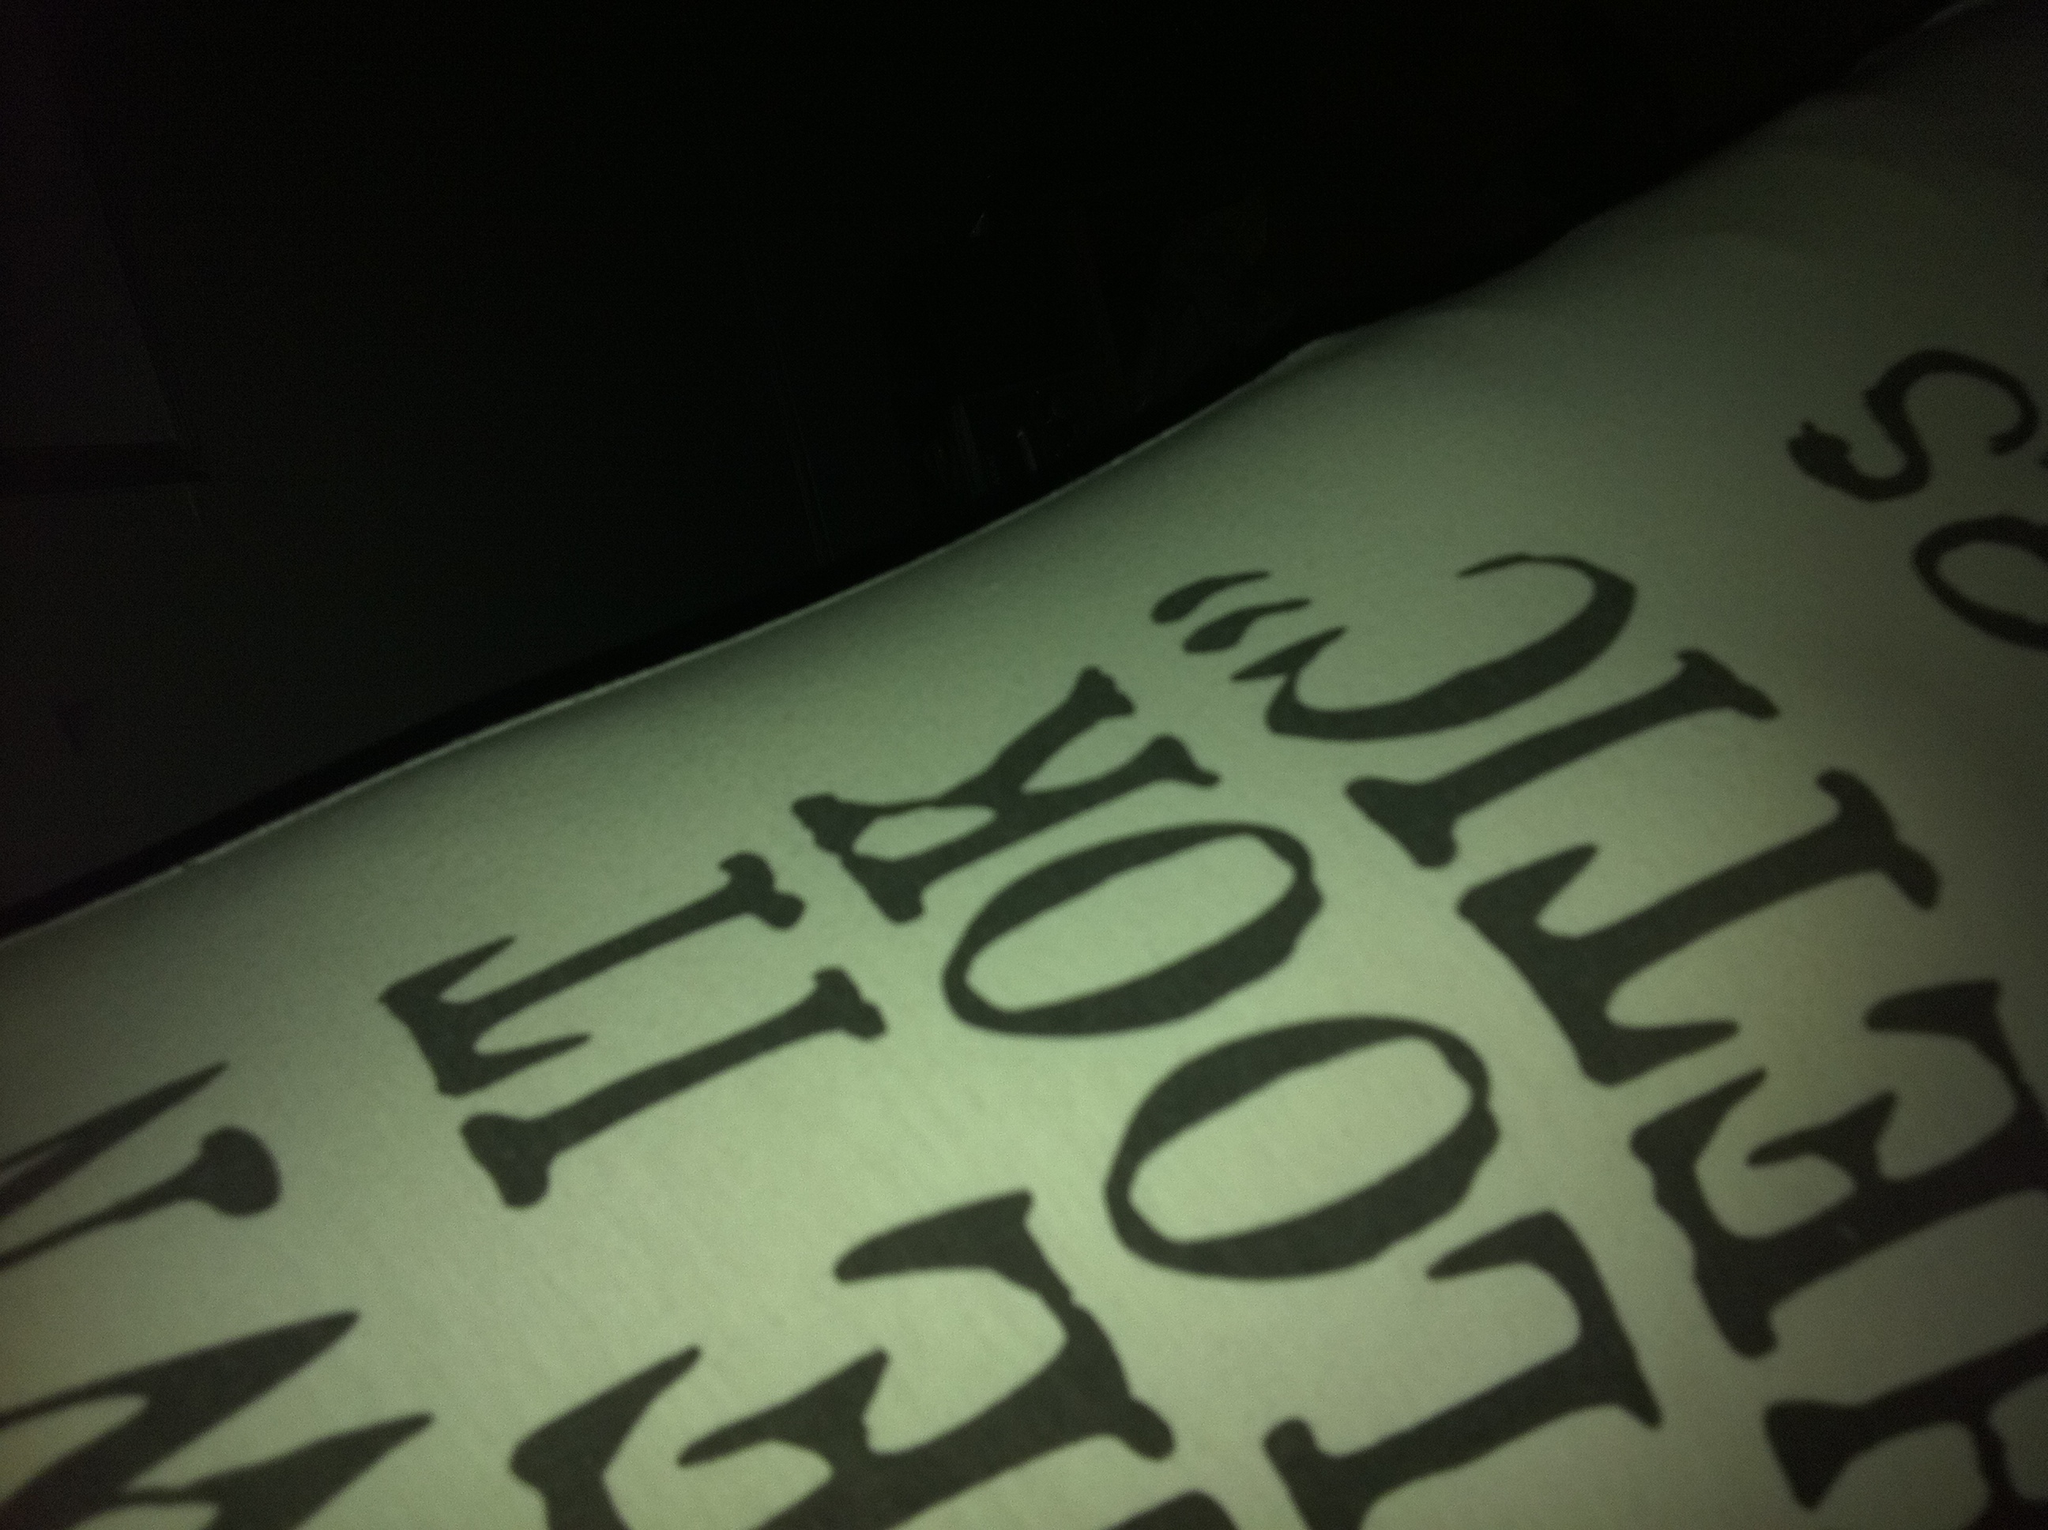Can you tell me more about the text in this image? The image shows a white surface with black text printed on it. The words appear to be in a decorative or stylized font. The text is partially visible, so it's challenging to read the entire phrase or message. The letters 'L', 'O', and 'K' are particularly visible, possibly forming the word 'LOOK'. 